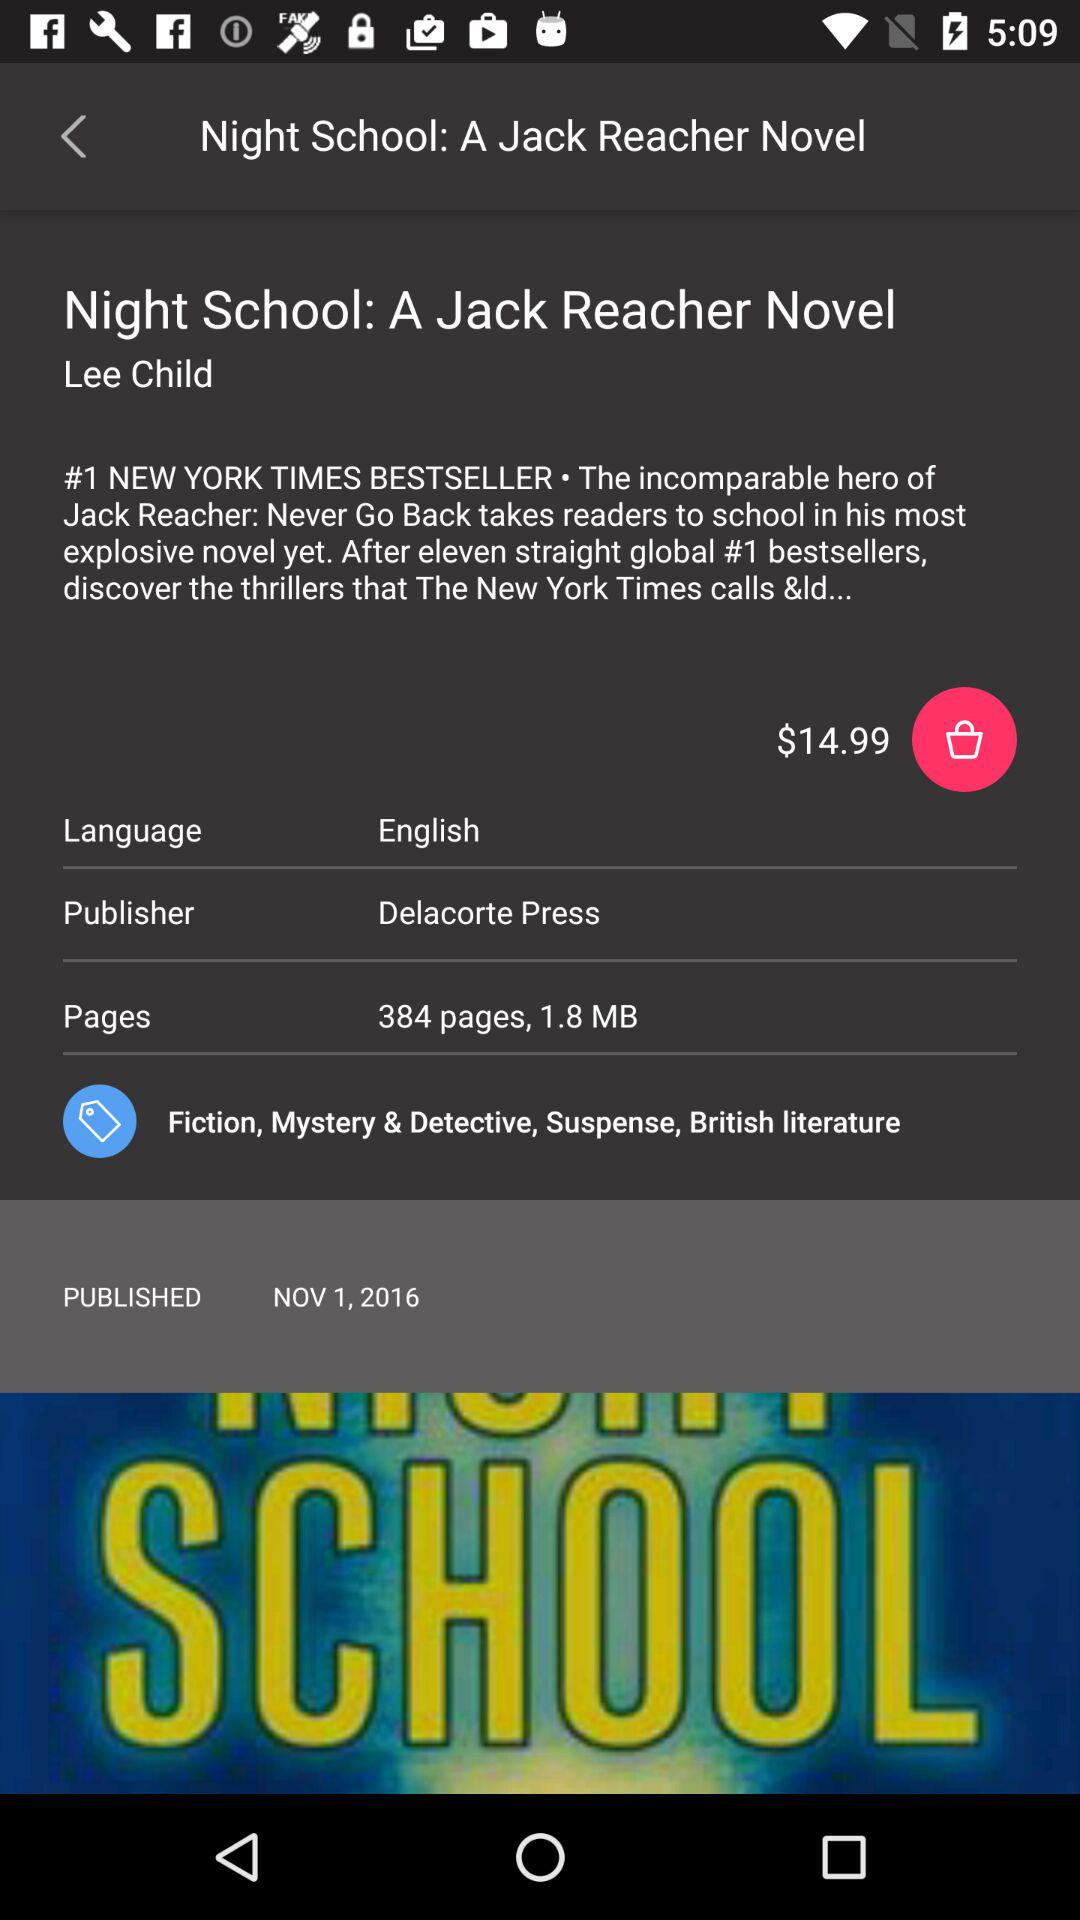How much is the book?
Answer the question using a single word or phrase. $14.99 